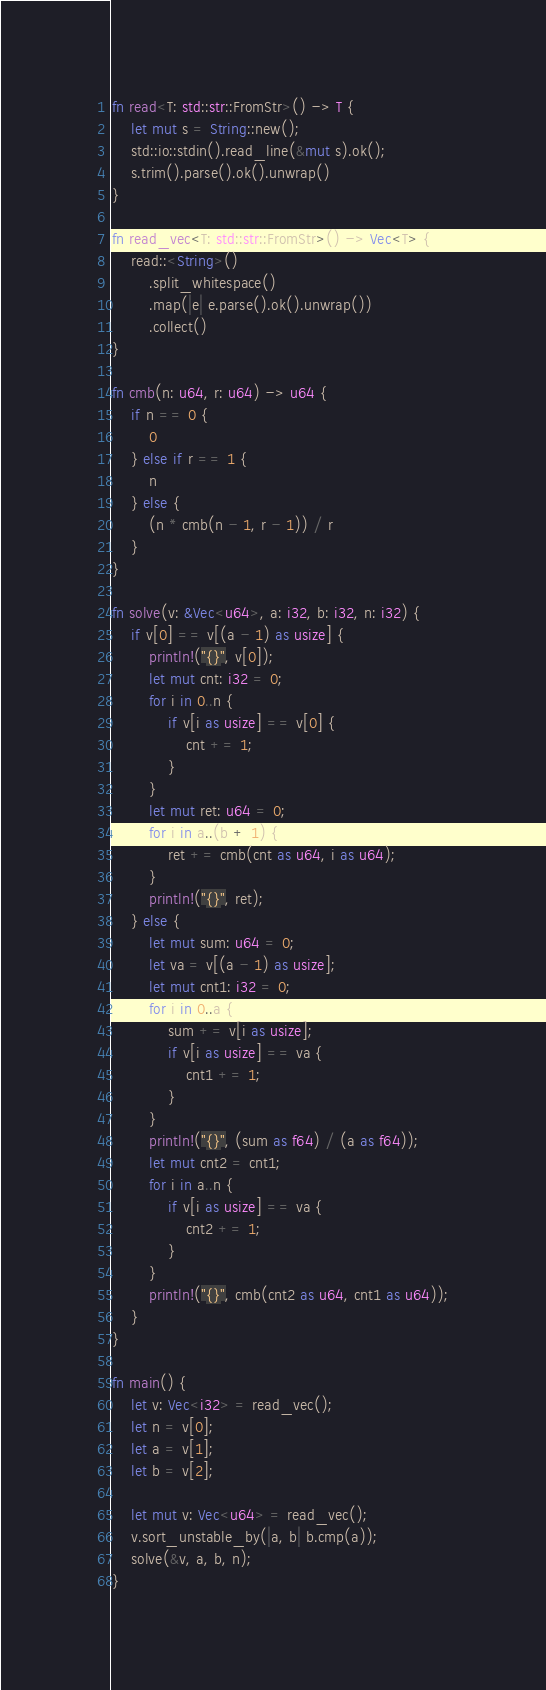Convert code to text. <code><loc_0><loc_0><loc_500><loc_500><_Rust_>fn read<T: std::str::FromStr>() -> T {
    let mut s = String::new();
    std::io::stdin().read_line(&mut s).ok();
    s.trim().parse().ok().unwrap()
}

fn read_vec<T: std::str::FromStr>() -> Vec<T> {
    read::<String>()
        .split_whitespace()
        .map(|e| e.parse().ok().unwrap())
        .collect()
}

fn cmb(n: u64, r: u64) -> u64 {
    if n == 0 {
        0
    } else if r == 1 {
        n
    } else {
        (n * cmb(n - 1, r - 1)) / r
    }
}

fn solve(v: &Vec<u64>, a: i32, b: i32, n: i32) {
    if v[0] == v[(a - 1) as usize] {
        println!("{}", v[0]);
        let mut cnt: i32 = 0;
        for i in 0..n {
            if v[i as usize] == v[0] {
                cnt += 1;
            }
        }
        let mut ret: u64 = 0;
        for i in a..(b + 1) {
            ret += cmb(cnt as u64, i as u64);
        }
        println!("{}", ret);
    } else {
        let mut sum: u64 = 0;
        let va = v[(a - 1) as usize];
        let mut cnt1: i32 = 0;
        for i in 0..a {
            sum += v[i as usize];
            if v[i as usize] == va {
                cnt1 += 1;
            }
        }
        println!("{}", (sum as f64) / (a as f64));
        let mut cnt2 = cnt1;
        for i in a..n {
            if v[i as usize] == va {
                cnt2 += 1;
            }
        }
        println!("{}", cmb(cnt2 as u64, cnt1 as u64));
    }
}

fn main() {
    let v: Vec<i32> = read_vec();
    let n = v[0];
    let a = v[1];
    let b = v[2];

    let mut v: Vec<u64> = read_vec();
    v.sort_unstable_by(|a, b| b.cmp(a));
    solve(&v, a, b, n);
}
</code> 